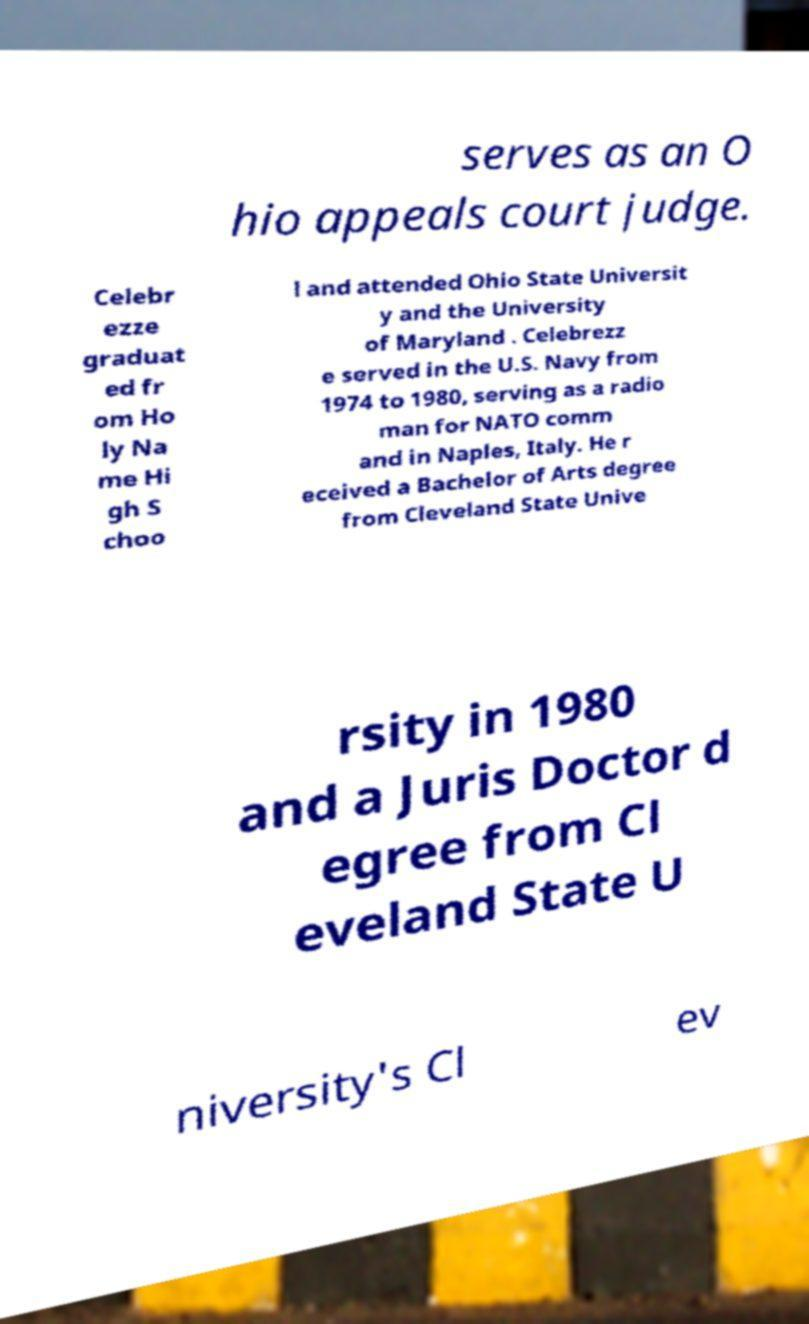Could you extract and type out the text from this image? serves as an O hio appeals court judge. Celebr ezze graduat ed fr om Ho ly Na me Hi gh S choo l and attended Ohio State Universit y and the University of Maryland . Celebrezz e served in the U.S. Navy from 1974 to 1980, serving as a radio man for NATO comm and in Naples, Italy. He r eceived a Bachelor of Arts degree from Cleveland State Unive rsity in 1980 and a Juris Doctor d egree from Cl eveland State U niversity's Cl ev 